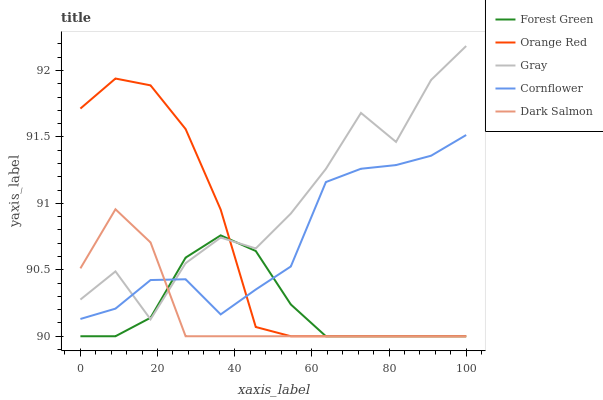Does Dark Salmon have the minimum area under the curve?
Answer yes or no. Yes. Does Gray have the maximum area under the curve?
Answer yes or no. Yes. Does Forest Green have the minimum area under the curve?
Answer yes or no. No. Does Forest Green have the maximum area under the curve?
Answer yes or no. No. Is Forest Green the smoothest?
Answer yes or no. Yes. Is Gray the roughest?
Answer yes or no. Yes. Is Dark Salmon the smoothest?
Answer yes or no. No. Is Dark Salmon the roughest?
Answer yes or no. No. Does Forest Green have the lowest value?
Answer yes or no. Yes. Does Cornflower have the lowest value?
Answer yes or no. No. Does Gray have the highest value?
Answer yes or no. Yes. Does Dark Salmon have the highest value?
Answer yes or no. No. Does Gray intersect Forest Green?
Answer yes or no. Yes. Is Gray less than Forest Green?
Answer yes or no. No. Is Gray greater than Forest Green?
Answer yes or no. No. 